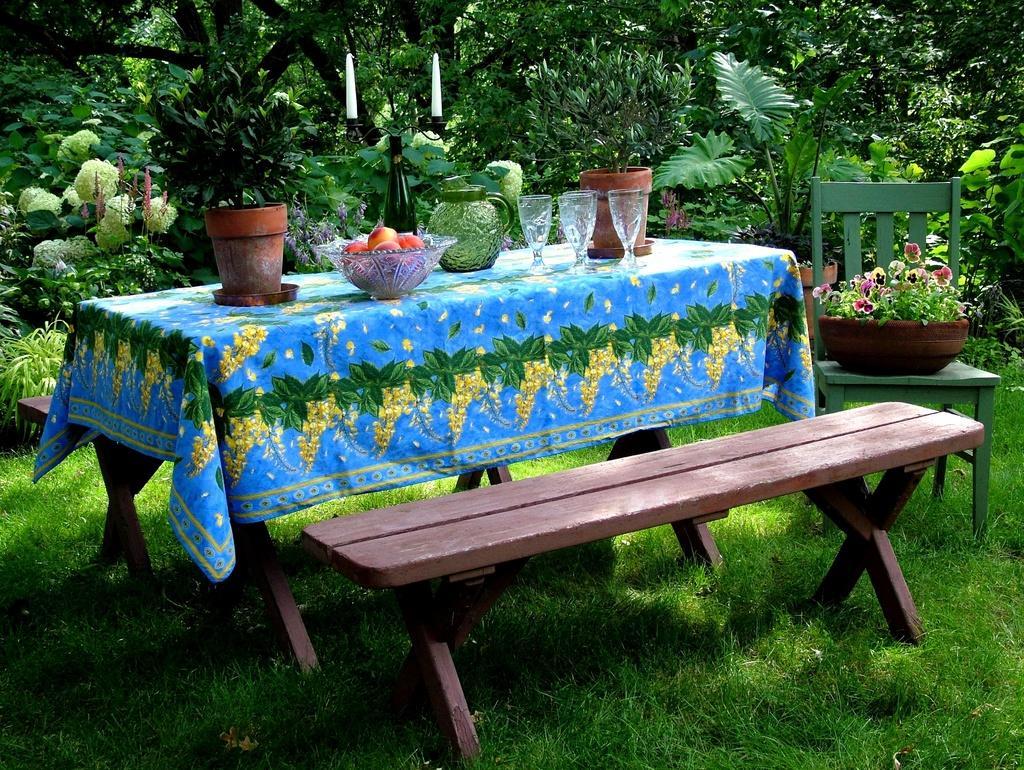Can you describe this image briefly? In this picture we can see a table, bench, plants, trees. On the table we can find a table cloth on that we can see some plants, bowl of fruits, glasses, jug, and candles. Beside to it there is a chair on that we can find a flowers and plant. 